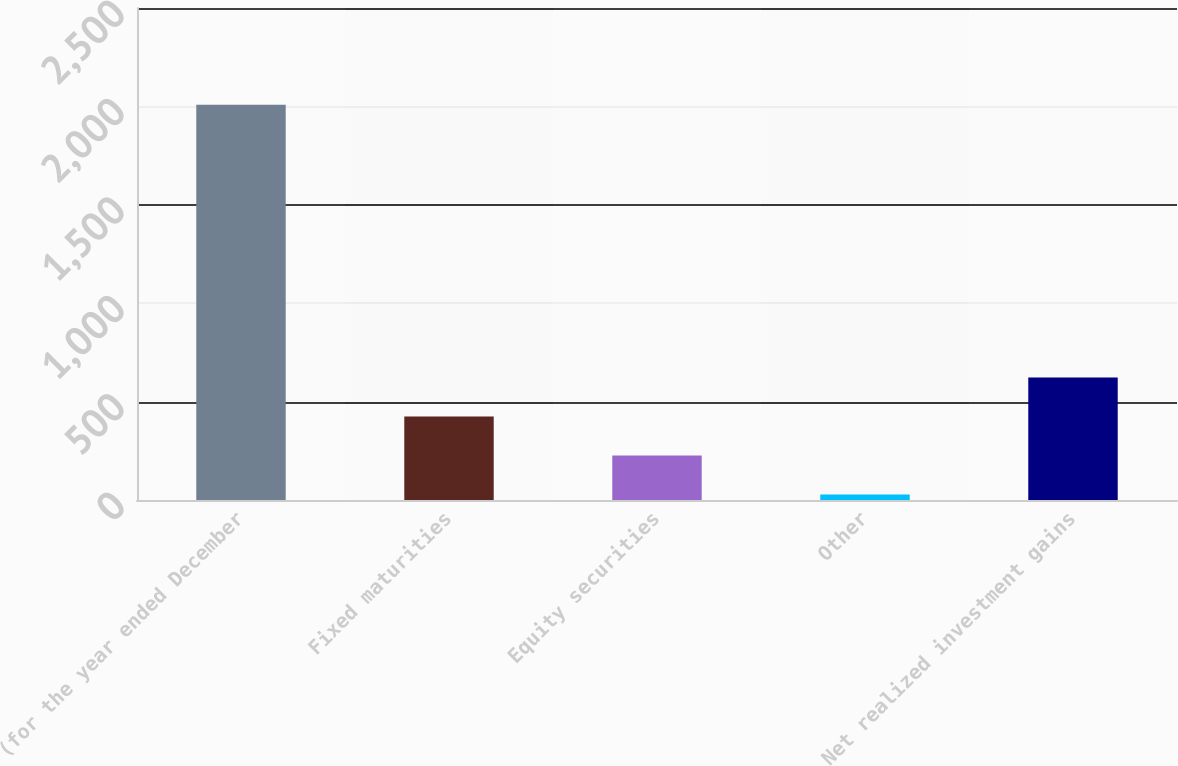<chart> <loc_0><loc_0><loc_500><loc_500><bar_chart><fcel>(for the year ended December<fcel>Fixed maturities<fcel>Equity securities<fcel>Other<fcel>Net realized investment gains<nl><fcel>2008<fcel>424<fcel>226<fcel>28<fcel>622<nl></chart> 